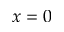<formula> <loc_0><loc_0><loc_500><loc_500>x = 0</formula> 